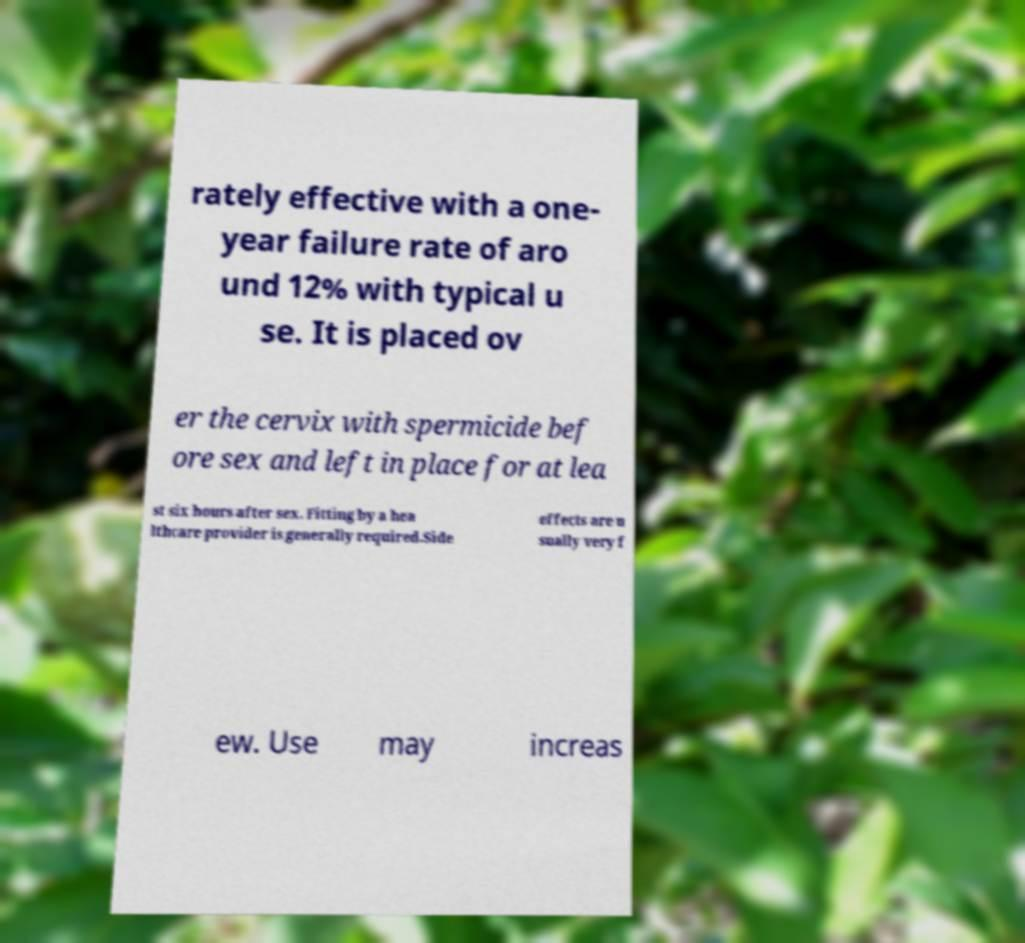Can you read and provide the text displayed in the image?This photo seems to have some interesting text. Can you extract and type it out for me? rately effective with a one- year failure rate of aro und 12% with typical u se. It is placed ov er the cervix with spermicide bef ore sex and left in place for at lea st six hours after sex. Fitting by a hea lthcare provider is generally required.Side effects are u sually very f ew. Use may increas 